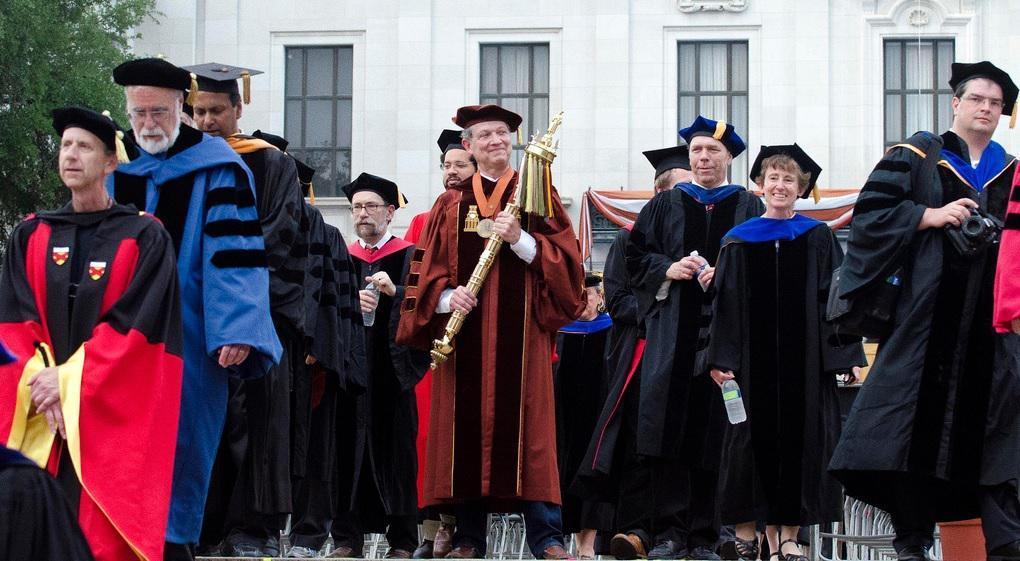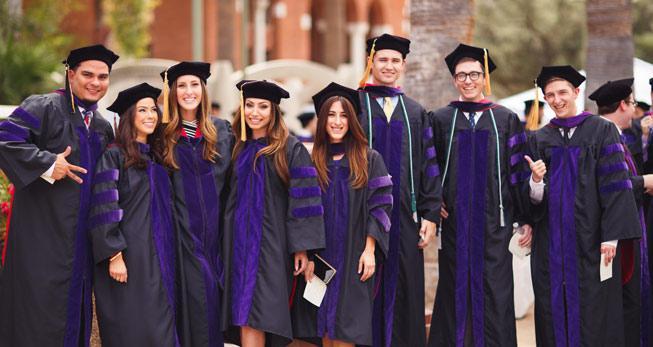The first image is the image on the left, the second image is the image on the right. For the images shown, is this caption "One image shows a group of graduates posed outdoors wearing different colored robes with three black stripes per sleeve." true? Answer yes or no. Yes. The first image is the image on the left, the second image is the image on the right. Assess this claim about the two images: "The graduates in each picture are posing outside.". Correct or not? Answer yes or no. Yes. 